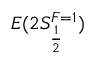Convert formula to latex. <formula><loc_0><loc_0><loc_500><loc_500>E ( 2 S _ { \frac { 1 } { 2 } } ^ { F = 1 } )</formula> 